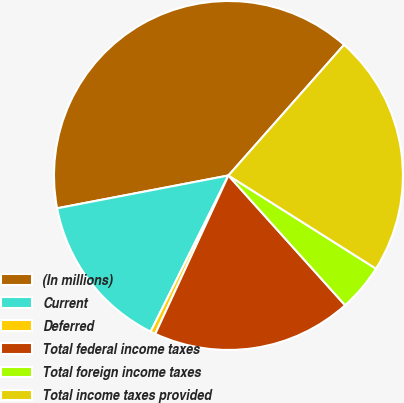Convert chart to OTSL. <chart><loc_0><loc_0><loc_500><loc_500><pie_chart><fcel>(In millions)<fcel>Current<fcel>Deferred<fcel>Total federal income taxes<fcel>Total foreign income taxes<fcel>Total income taxes provided<nl><fcel>39.54%<fcel>14.63%<fcel>0.47%<fcel>18.54%<fcel>4.38%<fcel>22.44%<nl></chart> 